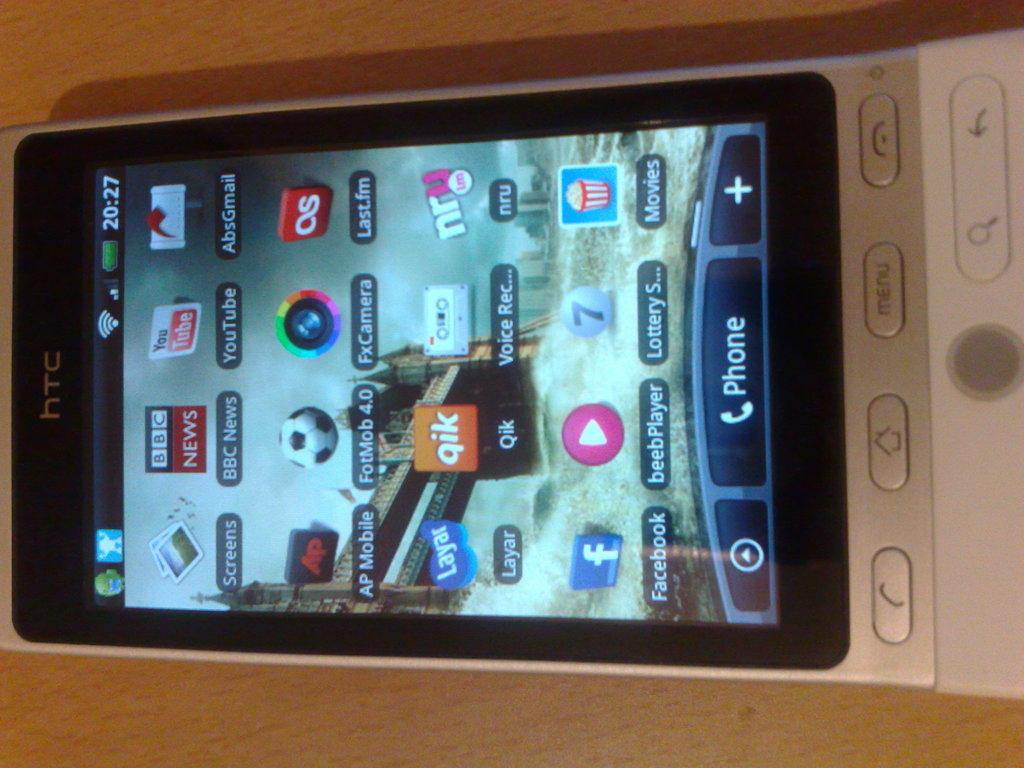Provide a one-sentence caption for the provided image. A HTC cellphone with its screen on is laying side ways on a wooden table. 